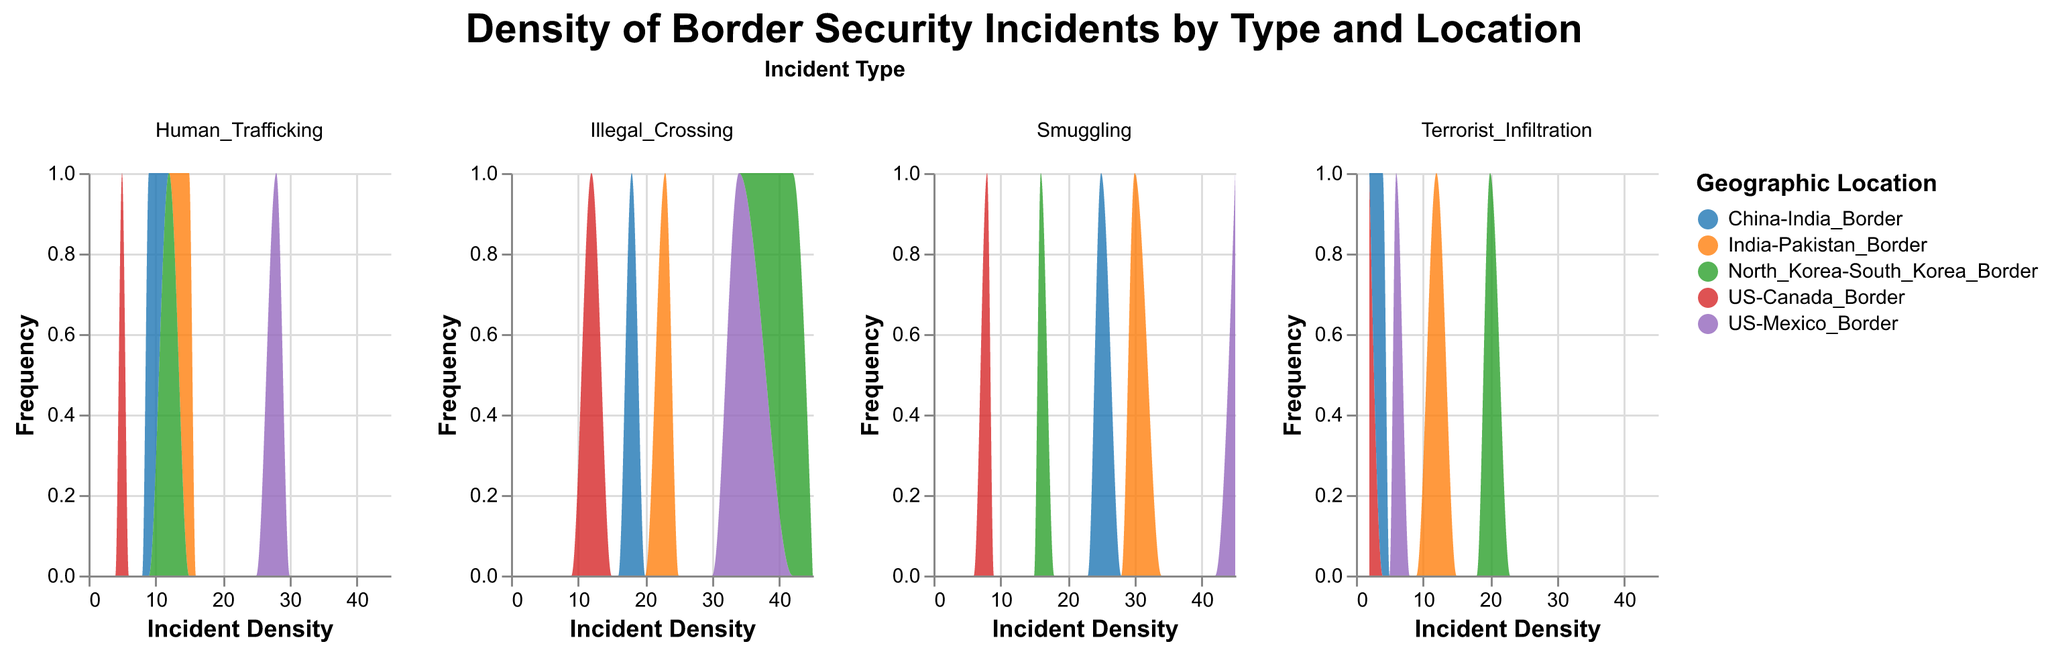What is the title of the plot? The title is presented at the top of the plot in bold font and clearly states what the data visualization represents.
Answer: Density of Border Security Incidents by Type and Location How many different incident types are represented in the plot? The "Incident Type" field categorizes the data. The plot is faceted by the "Incident Type" field into separate columns for each type.
Answer: Five incident types Which border has the highest incident density for Illegal Crossing? By looking at the density plot for "Illegal Crossing," we observe the height of the density peaks for different geographic locations. The US-Mexico Border has the highest peak at 34.
Answer: US-Mexico Border What is the geographic location with the highest incident density for Smuggling? From examining the Smuggling subplot, the US-Mexico Border has the highest density, reaching up to 45.
Answer: US-Mexico Border Among the given geographic locations, which one has the lowest frequency for Terrorist Infiltration? The frequency is represented on the y-axis, and by comparing the heights of the density curves, the US-Canada Border has the lowest frequency at 2.
Answer: US-Canada Border What is the combined density of Illegal Crossing incidents at the US-Mexico Border and the North Korea-South Korea Border? Sum the Incident Density values for these two locations under Illegal Crossing: 34 (US-Mexico) + 42 (North Korea-South Korea).
Answer: 76 Which incident type has the most balanced densities across all geographic locations? Observe the subplots for each incident type and compare the density curves. Human Trafficking has relatively balanced densities across different locations.
Answer: Human Trafficking Compare the highest density for Human Trafficking and for Smuggling. Which one is greater and by how much? Look at the peak density of each incident type. For Human Trafficking, the peak density is 28 at the US-Mexico Border and for Smuggling, it is 45 at the US-Mexico Border. Difference = 45 - 28.
Answer: Smuggling by 17 Which incident type has the highest recorded density across all geographic locations? By observing each subplot, Smuggling at the US-Mexico Border has the highest density, recorded at 45.
Answer: Smuggling How does the density of Human Trafficking incidents at the India-Pakistan Border compare to that at the China-India Border? The incident density of Human Trafficking at the India-Pakistan Border is 15, whereas at the China-India Border, it is 9. Compare these two values.
Answer: India-Pakistan Border is higher by 6 